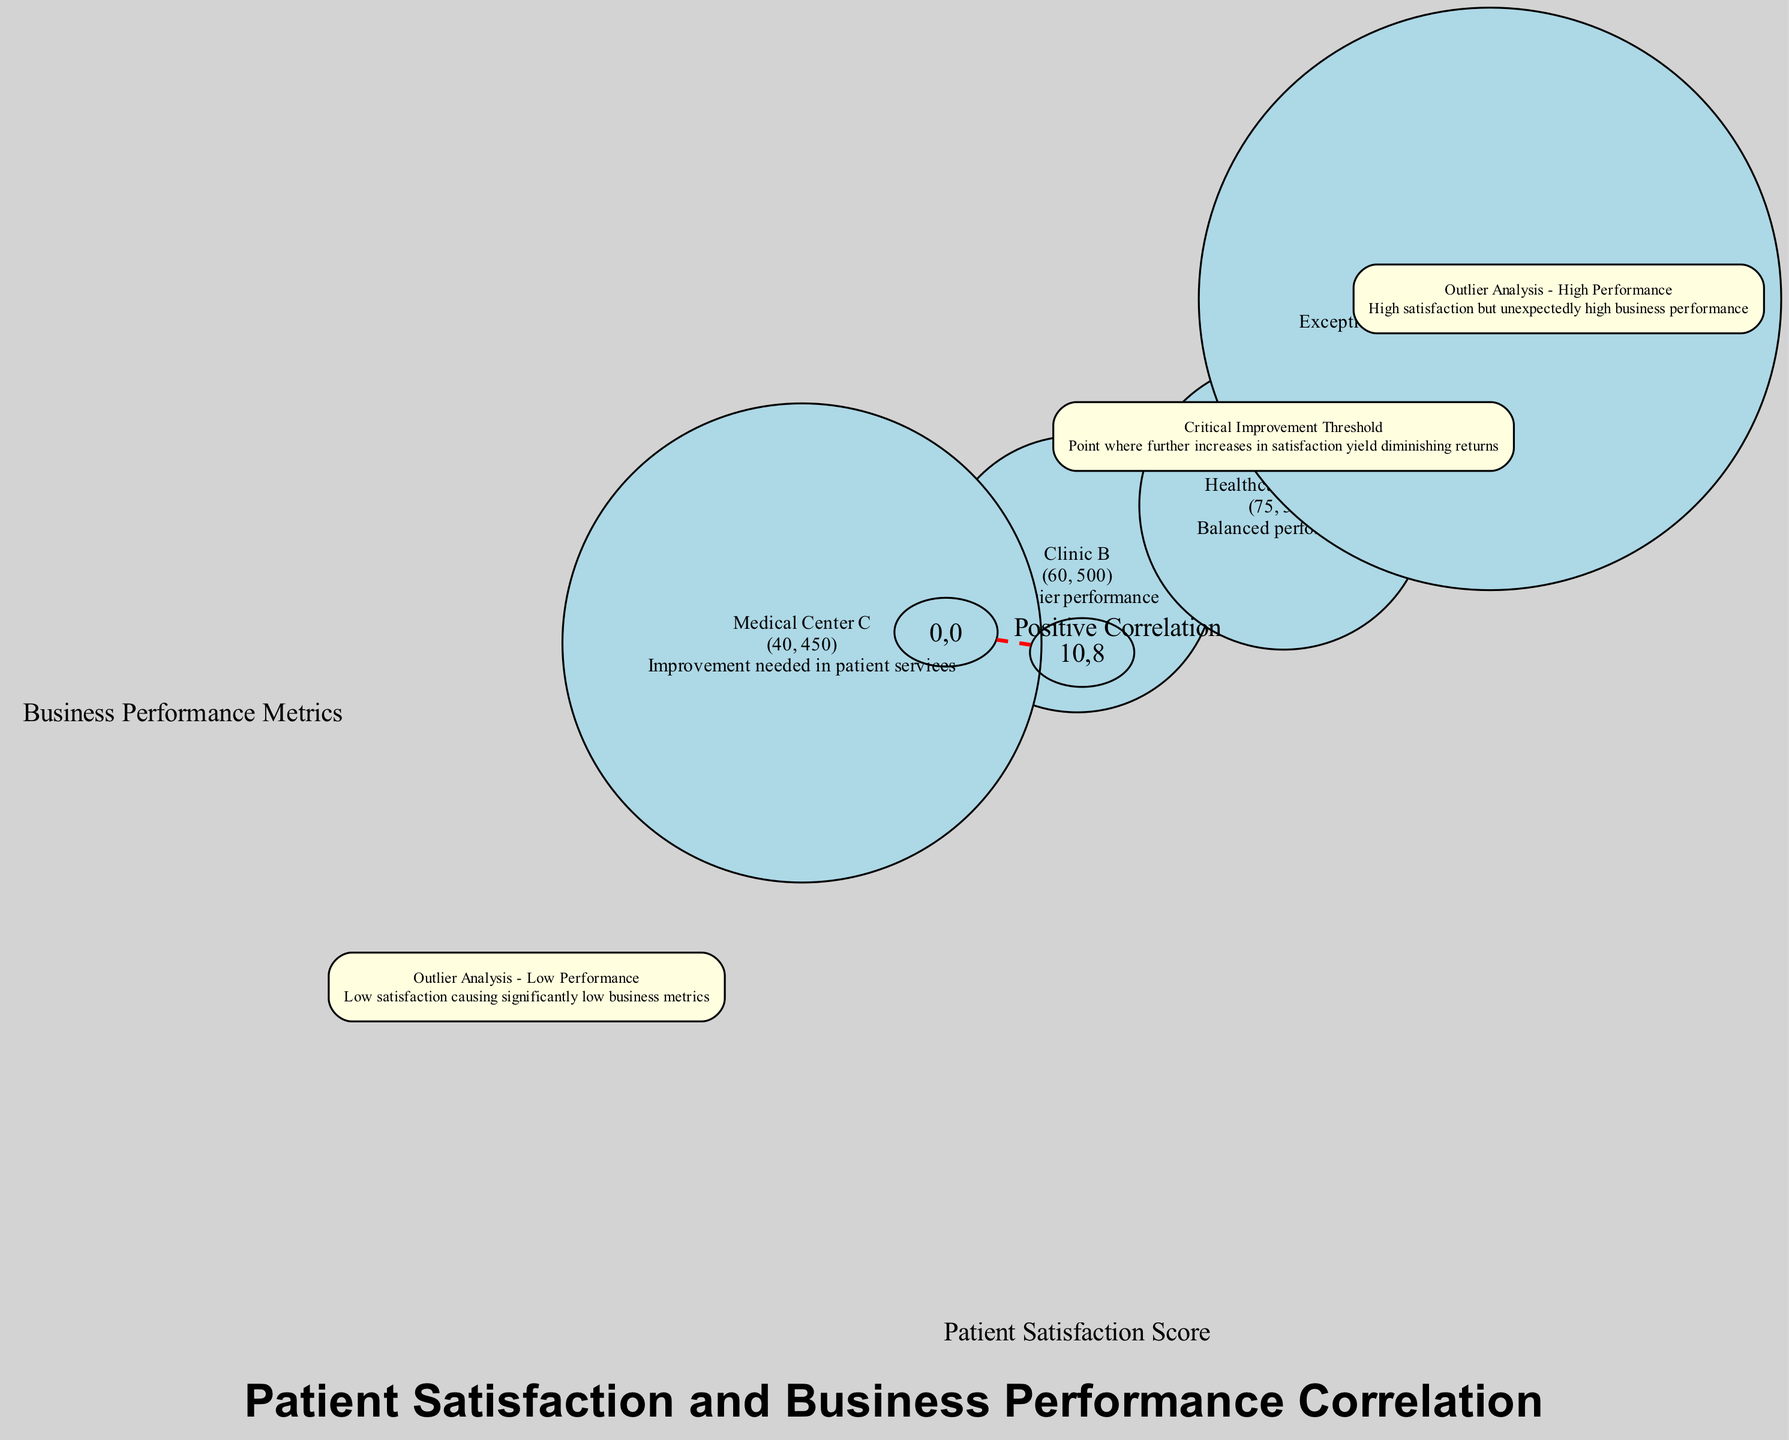What is the maximum Patient Satisfaction Score shown in the diagram? The Patient Satisfaction Score is represented on the x-axis of the diagram, with the highest point indicating 100. Therefore, the maximum score shown is 100.
Answer: 100 Which data point has a Business Performance Metric of 700? By examining the data points plotted on the scatter plot, Urgent Care E is annotated with a Business Performance Metric of 700.
Answer: Urgent Care E What is the label of the point located at the coordinates (95, 700)? The diagram includes an annotation specifically identifying the point at (95, 700) as "Outlier Analysis - High Performance," which describes its notable position.
Answer: Outlier Analysis - High Performance How many data points are above the Critical Improvement Threshold? The Critical Improvement Threshold is marked at the coordinates (75, 600). Examining the data points, we find that Hospital A, Urgent Care E, and Healthcare Group D all lie above this threshold. This results in a count of three data points.
Answer: 3 What is the correlation described in the trend line? The trend line is labeled with the description "Positive Correlation," indicating that as patient satisfaction scores increase, business performance metrics also increase.
Answer: Positive Correlation Which point is identified as needing improvement in patient services? The diagram notes Medical Center C, plotted at coordinates (40, 450), with a description indicating the need for improvement in patient services, clearly stating this directly in the annotation.
Answer: Medical Center C What coordinates are listed for the annotation labeled "Critical Improvement Threshold"? The annotation specifies its coordinates as (75, 600), directly evidenced in the labels of the diagonal line on the scatter plot reflecting the significant aspect of patient satisfaction and business performance.
Answer: 75, 600 Which data point has the lowest Patient Satisfaction Score? The data point Medical Center C is plotted at the lowest Patient Satisfaction Score of 40, making it the point representing the lowest satisfaction within the presented data.
Answer: Medical Center C What does the trend line indicate about the relationship? The trend line, described as showing a positive correlation, indicates that increased patient satisfaction scores are associated with better business performance metrics, denoting a consistent relationship across the data.
Answer: Higher satisfaction yields better performance 